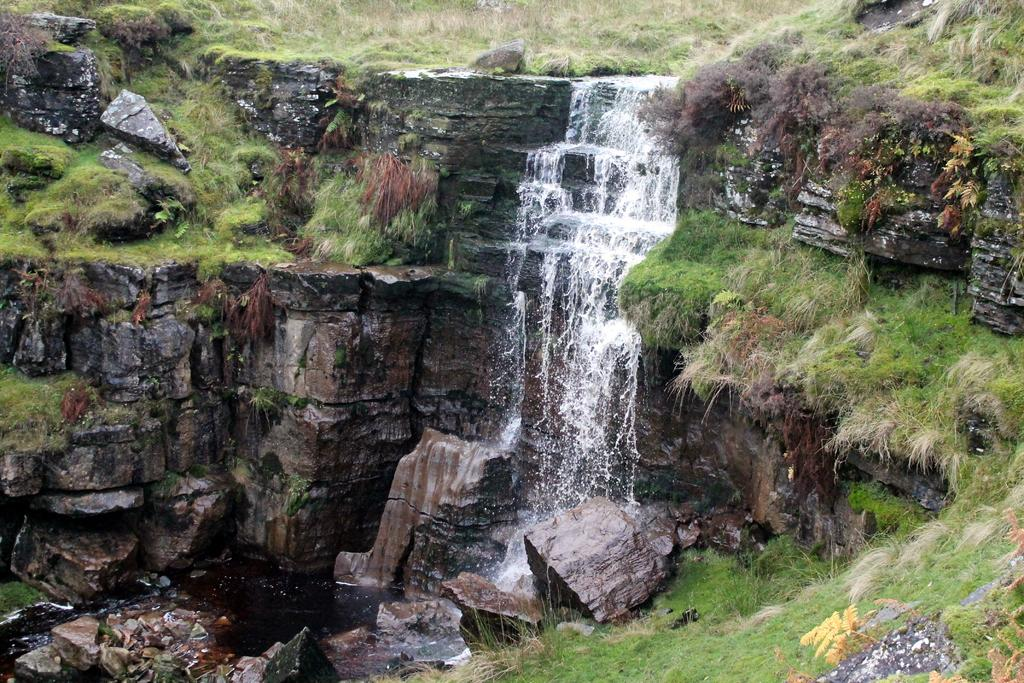What natural feature is the main subject of the image? There is a waterfall in the image. What type of geological formation can be seen in the image? There are rocks in the image. What type of vegetation is present in the image? There is grass in the image. What substance is the waterfall made of in the image? The waterfall is made of water, not a substance. Can you see the thumb of the photographer in the image? There is no thumb visible in the image. 